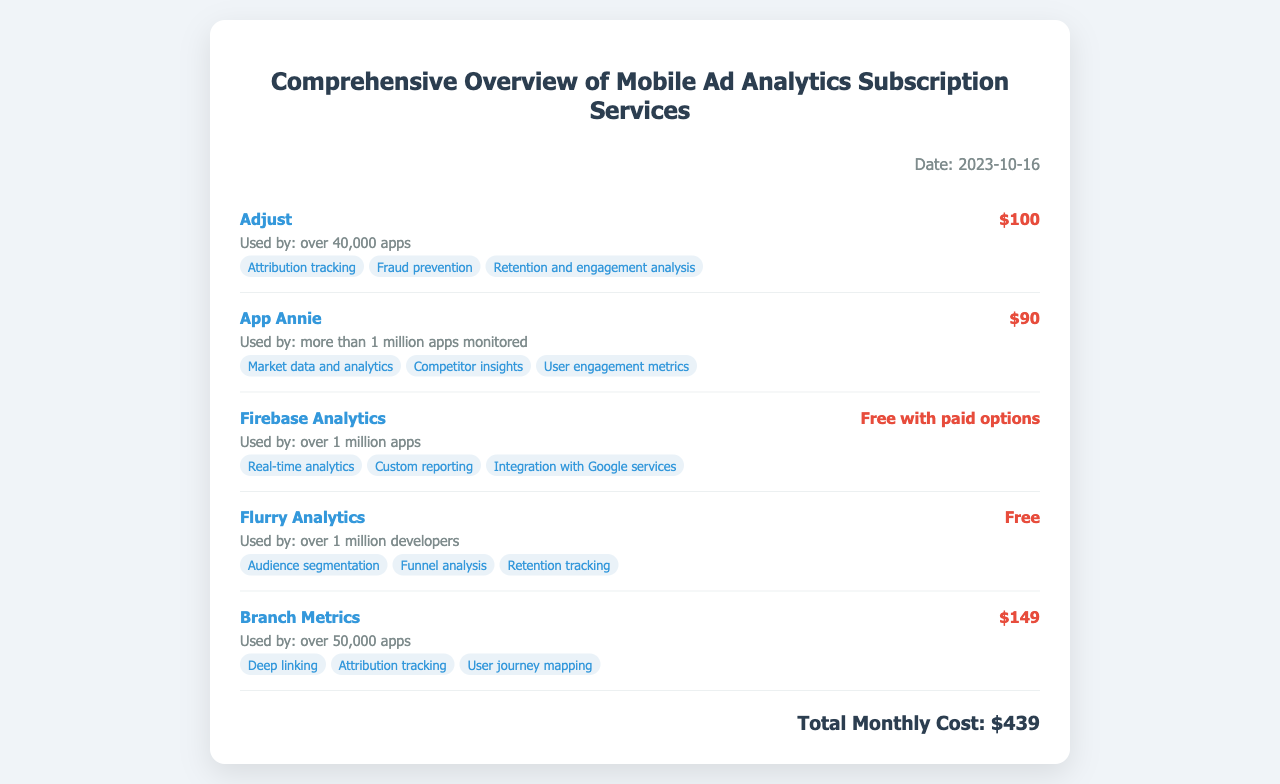What is the date of the document? The date is mentioned in the top right corner of the document as "2023-10-16".
Answer: 2023-10-16 How many apps use Adjust? The usage statistics state that Adjust is used by "over 40,000 apps".
Answer: over 40,000 apps What is the cost of App Annie? The document lists the cost of App Annie as "$90".
Answer: $90 Which service is free with paid options? The document specifies that "Firebase Analytics" has a cost structure of "Free with paid options".
Answer: Firebase Analytics What are the key features of Branch Metrics? The key features listed for Branch Metrics include "Deep linking, Attribution tracking, User journey mapping".
Answer: Deep linking, Attribution tracking, User journey mapping What is the total monthly cost of the subscriptions? The total monthly cost is summarized at the bottom of the document as "$439".
Answer: $439 How many apps does Firebase Analytics serve? The usage statistics indicate that Firebase Analytics is used by "over 1 million apps".
Answer: over 1 million apps What is the service used by the most number of apps? The document indicates that "App Annie" is used by "more than 1 million apps monitored".
Answer: more than 1 million apps monitored What is the service with the highest subscription cost? Among the listed services, "Branch Metrics" is noted to have the highest cost at "$149".
Answer: $149 